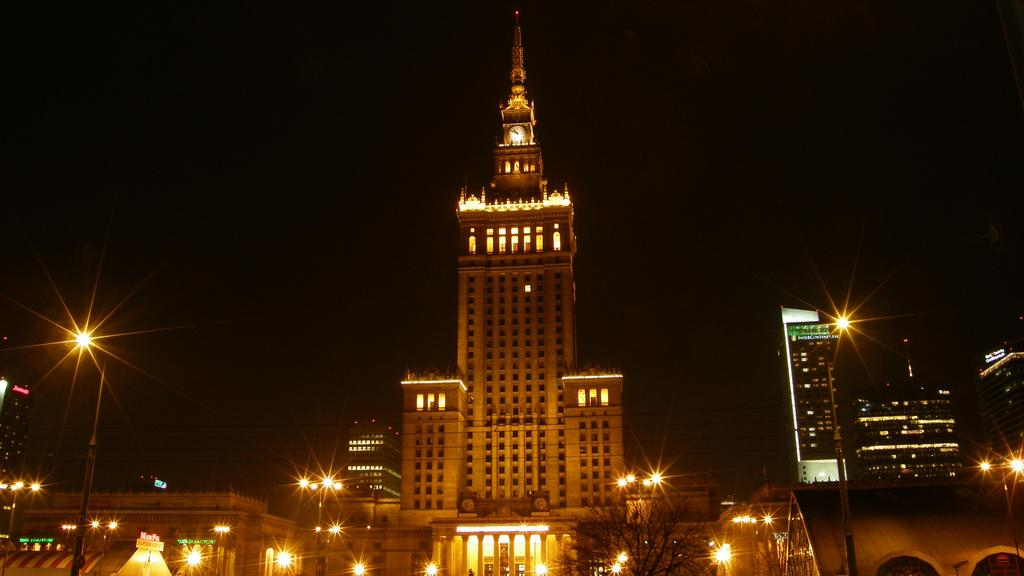What type of structures can be seen in the image? There are many buildings in the image. What is located in front of the buildings? There are trees in front of the buildings. What type of lighting is present in the image? There are street lights in the image. How would you describe the overall lighting in the image? The background of the image is dark. Where is the throne located in the image? There is no throne present in the image. What type of vehicle can be seen parked near the buildings? There is no vehicle mentioned or visible in the image. 